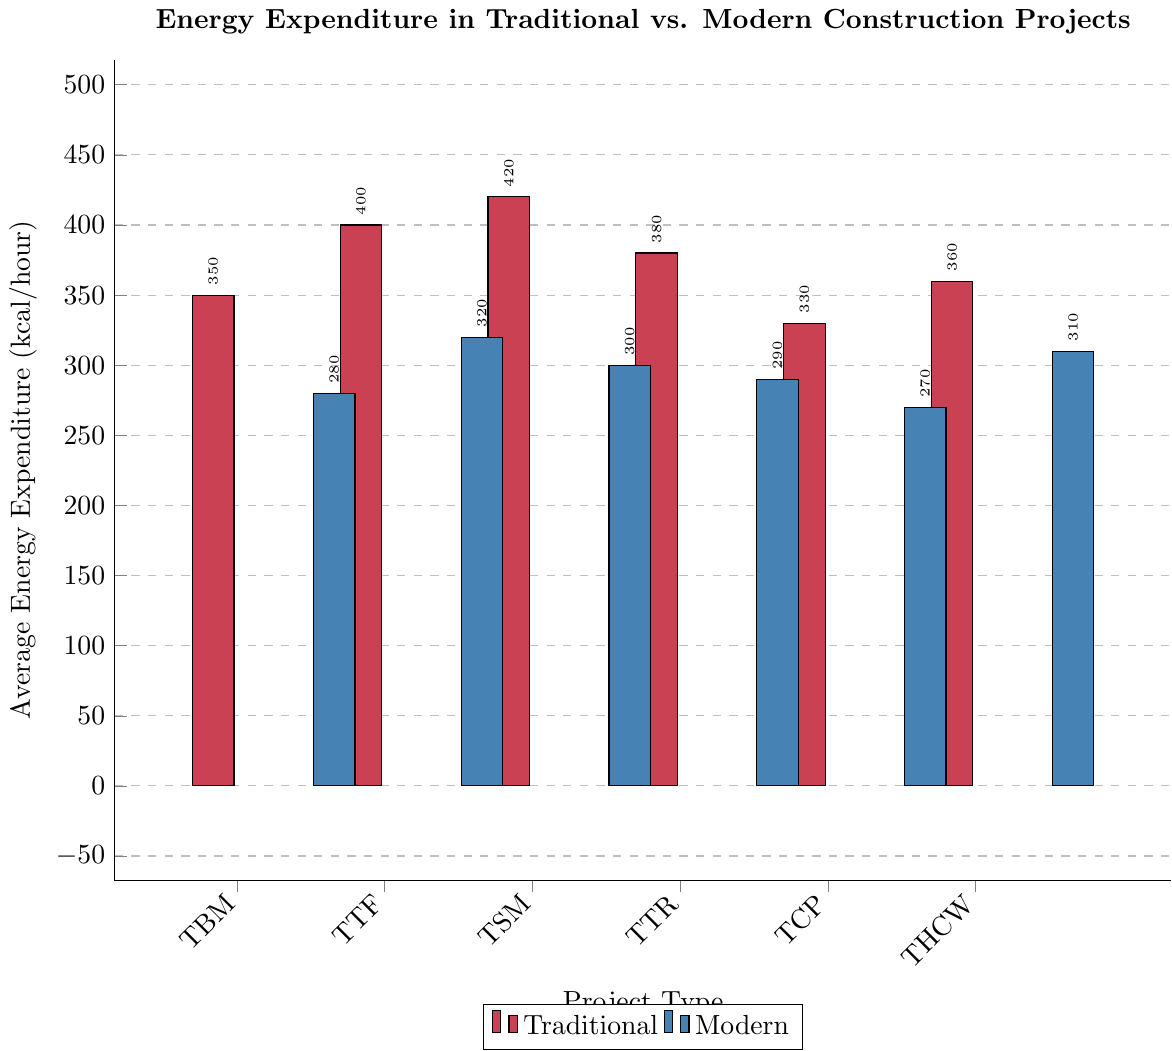Which project type has the highest average energy expenditure? The bar for Traditional Stone Masonry is the tallest among all bars, which indicates the highest value at 420 kcal/hour
Answer: Traditional Stone Masonry Which modern project type has the lowest average energy expenditure? The bar for Modern Spray Foam Insulation is the shortest among the modern project types, indicating 270 kcal/hour
Answer: Modern Spray Foam Insulation What is the difference in average energy expenditure between Traditional Timber Framing and Modern Steel Framework? Traditional Timber Framing has 400 kcal/hour and Modern Steel Framework has 320 kcal/hour. The difference is 400 - 320
Answer: 80 kcal/hour Which traditional project type has a higher average energy expenditure than Modern Glass Curtain Wall? We need to find traditional project types with values higher than Modern Glass Curtain Wall's 300 kcal/hour. Traditional Brick Masonry (350), Traditional Timber Framing (400), Traditional Stone Masonry (420), Traditional Thatched Roofing (380), Traditional Clay Plastering (330), and Traditional Hand-carved Woodwork (360) all qualify
Answer: Multiple: Traditional Brick Masonry, Traditional Timber Framing, Traditional Stone Masonry, Traditional Thatched Roofing, Traditional Clay Plastering, Traditional Hand-carved Woodwork What's the total average energy expenditure for all modern project types combined? Sum the values for all modern project types: 280 (MPA) + 320 (MSF) + 300 (MGCW) + 290 (MSPI) + 270 (MSFI) + 310 (MCCP) = 1770 kcal/hour
Answer: 1770 kcal/hour What is the average energy expenditure for traditional project types? First sum the values for traditional project types: 350 (TBM) + 400 (TTF) + 420 (TSM) + 380 (TTR) + 330 (TCP) + 360 (THCW) = 2240. Divide by the number of data points (6): 2240 / 6
Answer: 373.3 kcal/hour Which color bars represent traditional project types? The bars filled with the red color represent the traditional project types
Answer: Red Are there any modern project types with an average energy expenditure higher than any traditional project types with the lowest expenditure? The lowest average expenditure for traditional types is Traditional Clay Plastering at 330 kcal/hour. Modern Steel Framework (320), Modern Glass Curtain Wall (300), Modern Spray Foam Insulation (270), Modern Solar Panel Installation (290), and Modern CNC-cut Paneling (310) are all lower
Answer: No How much higher is the average expenditure for Traditional Hand-carved Woodwork compared to Modern Solar Panel Installation? Traditional Hand-carved Woodwork is at 360 kcal/hour and Modern Solar Panel Installation is at 290 kcal/hour. The difference is 360 - 290
Answer: 70 kcal/hour Among the modern project types, which has the second highest average energy expenditure? The highest for modern types is Modern Steel Framework at 320 kcal/hour. The second highest would be Modern CNC-cut Paneling at 310 kcal/hour
Answer: Modern CNC-cut Paneling 